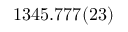<formula> <loc_0><loc_0><loc_500><loc_500>1 3 4 5 . 7 7 7 ( 2 3 )</formula> 